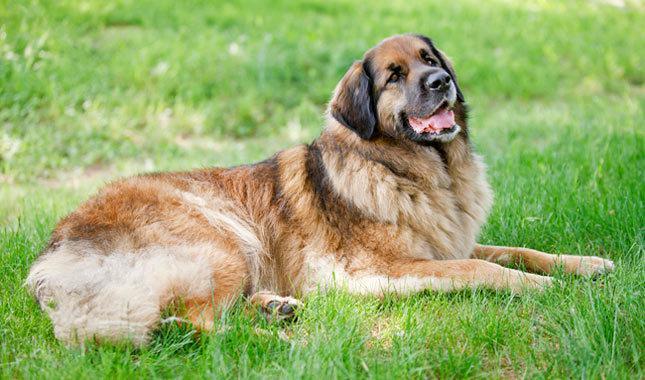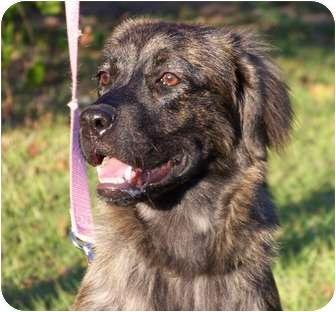The first image is the image on the left, the second image is the image on the right. For the images displayed, is the sentence "There is only one dog in each image and it has its mouth open." factually correct? Answer yes or no. Yes. The first image is the image on the left, the second image is the image on the right. Assess this claim about the two images: "All images show camera-facing dogs, and all dogs look similar in coloring and breed.". Correct or not? Answer yes or no. No. 